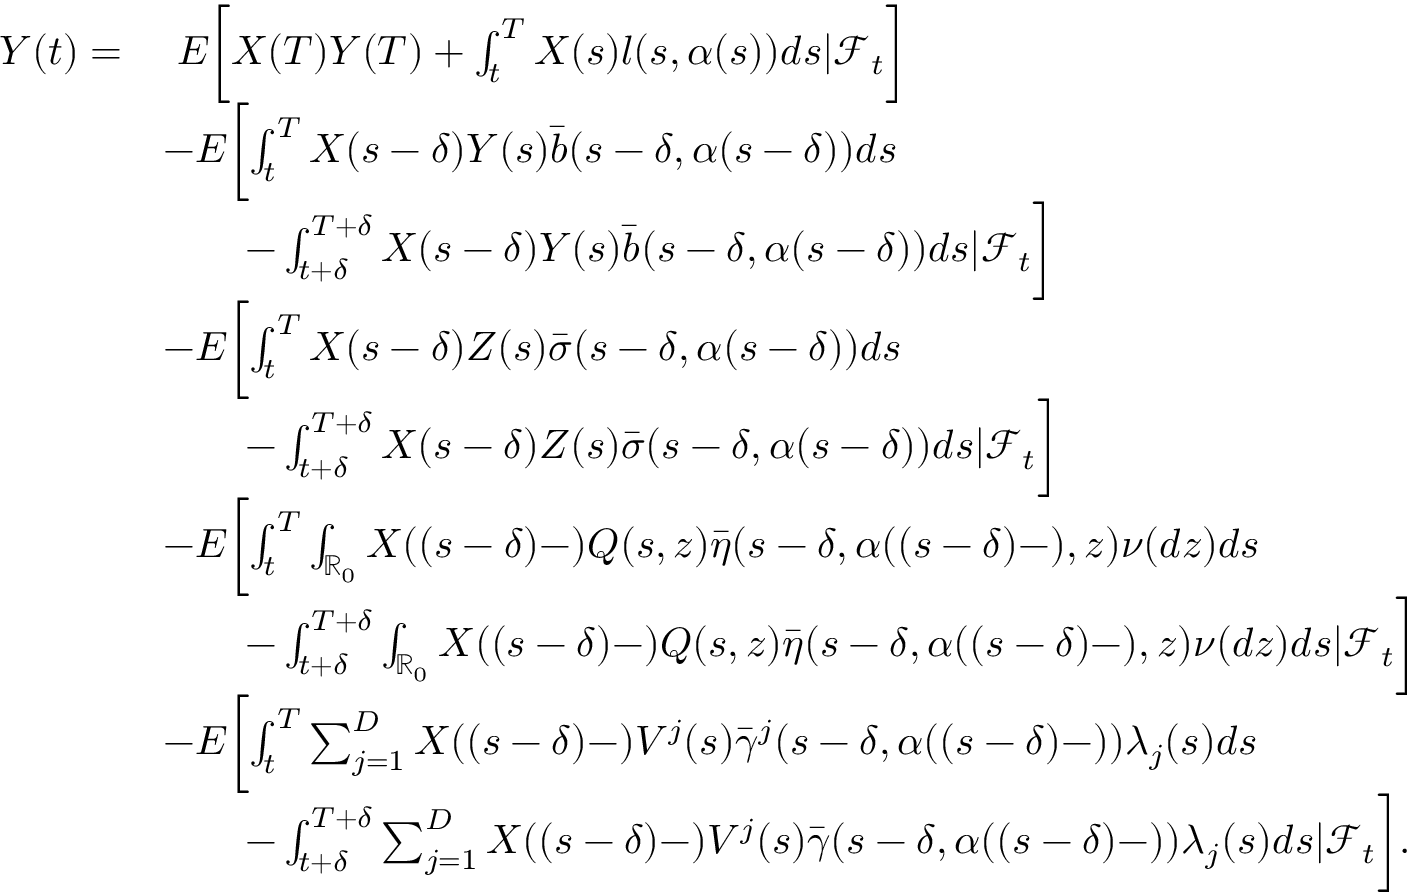<formula> <loc_0><loc_0><loc_500><loc_500>\begin{array} { r l } { Y ( t ) = } & { \ E \left [ X ( T ) Y ( T ) + \int _ { t } ^ { T } X ( s ) l ( s , \alpha ( s ) ) d s | \mathcal { F } _ { t } \right ] } \\ & { - E \left [ \int _ { t } ^ { T } X ( s - \delta ) Y ( s ) \bar { b } ( s - \delta , \alpha ( s - \delta ) ) d s } \\ & { \quad - \int _ { t + \delta } ^ { T + \delta } X ( s - \delta ) Y ( s ) \bar { b } ( s - \delta , \alpha ( s - \delta ) ) d s | \mathcal { F } _ { t } \right ] } \\ & { - E \left [ \int _ { t } ^ { T } X ( s - \delta ) Z ( s ) \bar { \sigma } ( s - \delta , \alpha ( s - \delta ) ) d s } \\ & { \quad - \int _ { t + \delta } ^ { T + \delta } X ( s - \delta ) Z ( s ) \bar { \sigma } ( s - \delta , \alpha ( s - \delta ) ) d s | \mathcal { F } _ { t } \right ] } \\ & { - E \left [ \int _ { t } ^ { T } \int _ { \mathbb { R } _ { 0 } } X ( ( s - \delta ) - ) Q ( s , z ) \bar { \eta } ( s - \delta , \alpha ( ( s - \delta ) - ) , z ) \nu ( d z ) d s } \\ & { \quad - \int _ { t + \delta } ^ { T + \delta } \int _ { \mathbb { R } _ { 0 } } X ( ( s - \delta ) - ) Q ( s , z ) \bar { \eta } ( s - \delta , \alpha ( ( s - \delta ) - ) , z ) \nu ( d z ) d s | \mathcal { F } _ { t } \right ] } \\ & { - E \left [ \int _ { t } ^ { T } \sum _ { j = 1 } ^ { D } X ( ( s - \delta ) - ) V ^ { j } ( s ) \bar { \gamma } ^ { j } ( s - \delta , \alpha ( ( s - \delta ) - ) ) \lambda _ { j } ( s ) d s } \\ & { \quad - \int _ { t + \delta } ^ { T + \delta } \sum _ { j = 1 } ^ { D } X ( ( s - \delta ) - ) V ^ { j } ( s ) \bar { \gamma } ( s - \delta , \alpha ( ( s - \delta ) - ) ) \lambda _ { j } ( s ) d s | \mathcal { F } _ { t } \right ] . } \end{array}</formula> 